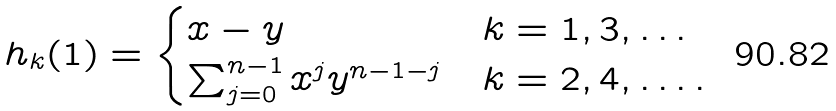<formula> <loc_0><loc_0><loc_500><loc_500>h _ { k } ( 1 ) = \begin{cases} x - y & k = 1 , 3 , \dots \\ \sum _ { j = 0 } ^ { n - 1 } x ^ { j } y ^ { n - 1 - j } & k = 2 , 4 , \dots . \end{cases}</formula> 